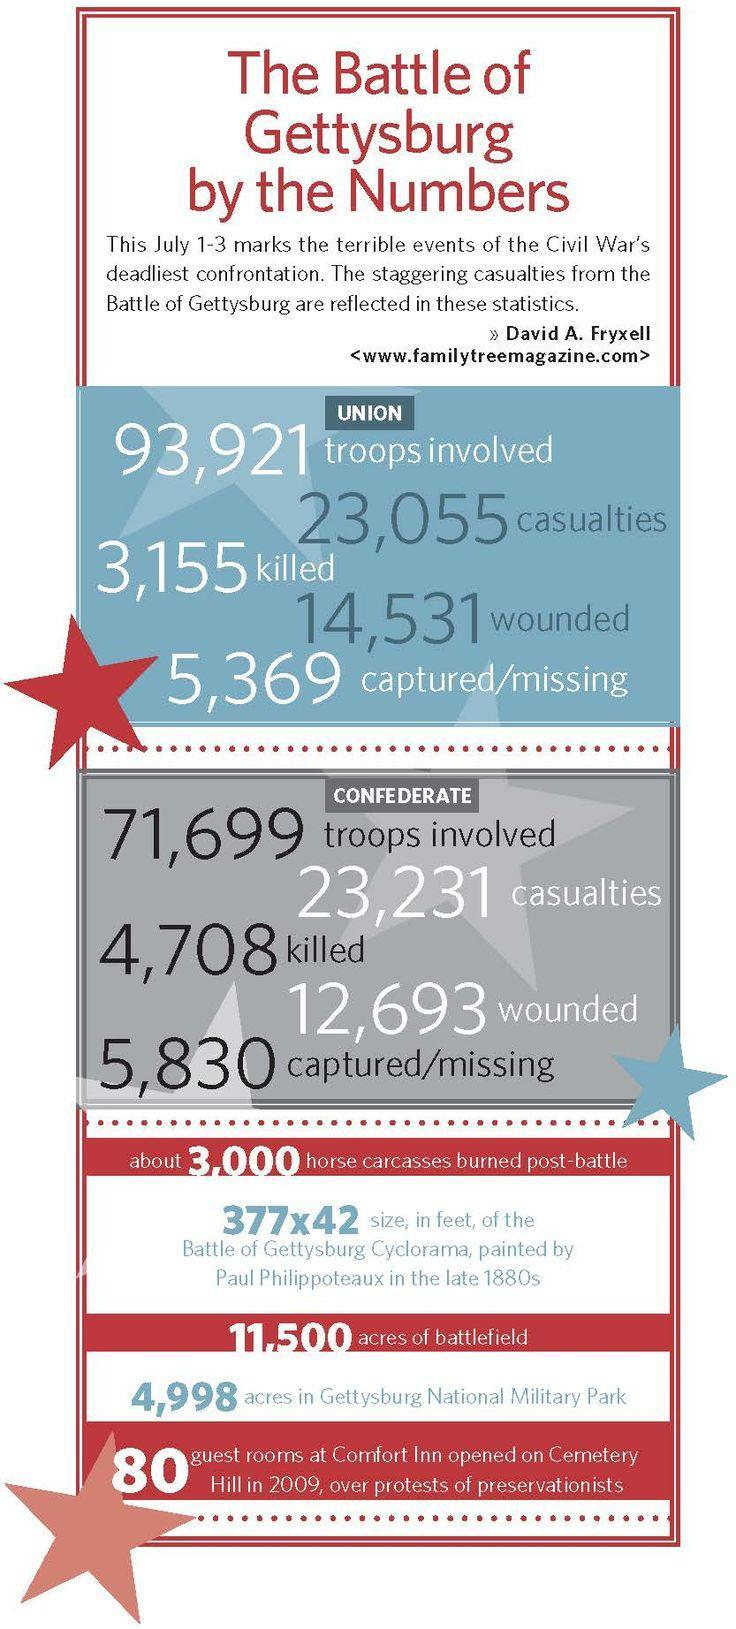How many people got caught or not found on the Union side during "The Battle of Gettysburg"?
Answer the question with a short phrase. 5,369 How many people got injured on the Confederate side during "The Battle of Gettysburg"? 12,693 What is the total no of soldiers who got murdered or injured or caught on the Confederate side? 23,231 How many people got caught or not found on the Confederate side during "The Battle of Gettysburg"? 5,830 How many people got either murdered or injured on the Union side during "The Battle of Gettysburg"? 17,686 How many people got either murdered or injured on the Confederate side during "The Battle of Gettysburg"? 17,401 How many people lost their lives on the Union side during "The Battle of Gettysburg"? 3,155 What is the total no of soldiers who got murdered or injured or caught on the Union side? 23,055 How many people got injured on the Union side during "The Battle of Gettysburg"? 14,531 How many people lost their lives on the Confederate side during "The Battle of Gettysburg"? 4,708 